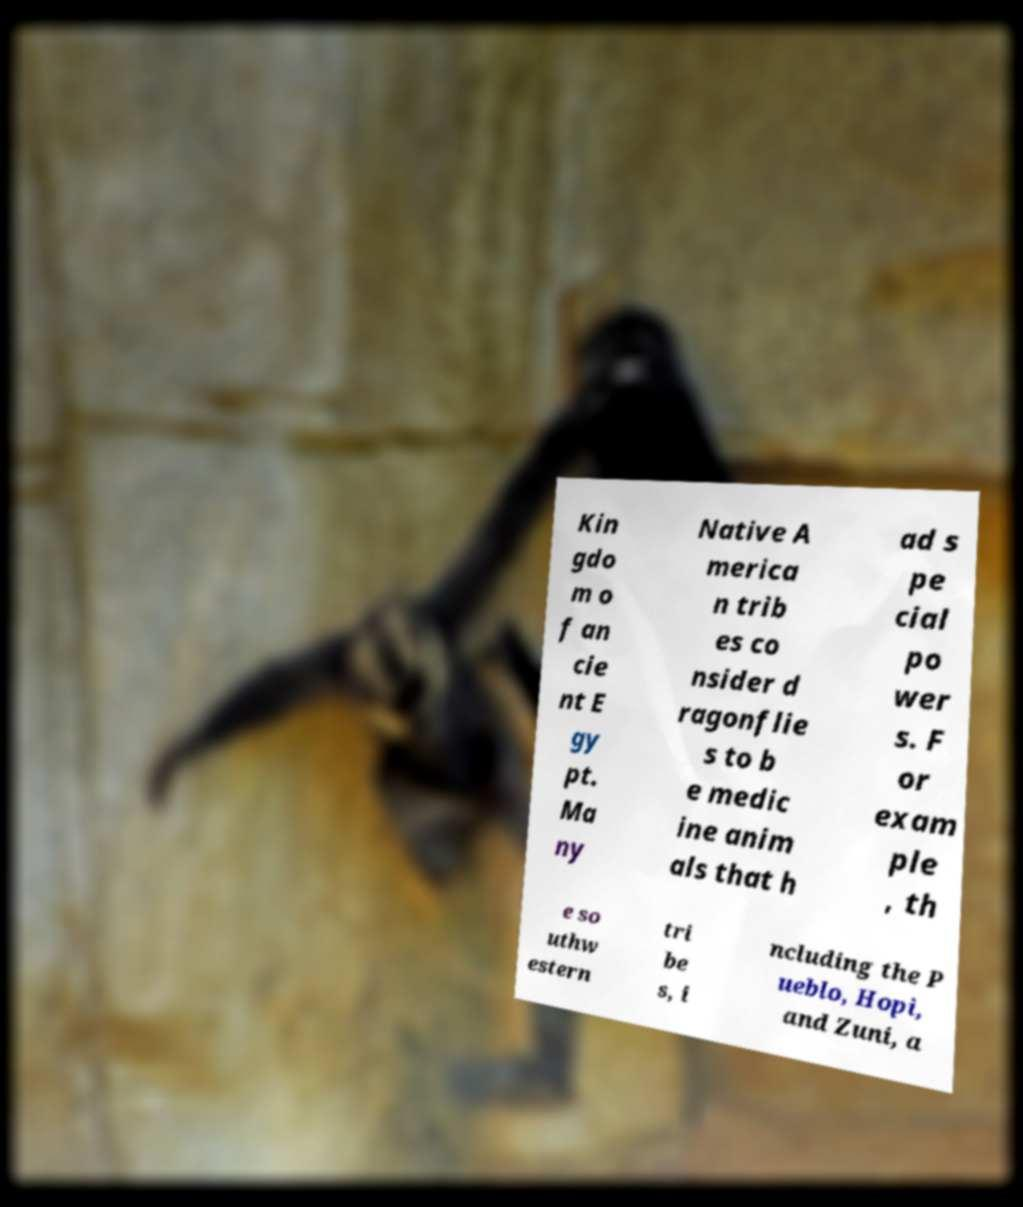Can you accurately transcribe the text from the provided image for me? Kin gdo m o f an cie nt E gy pt. Ma ny Native A merica n trib es co nsider d ragonflie s to b e medic ine anim als that h ad s pe cial po wer s. F or exam ple , th e so uthw estern tri be s, i ncluding the P ueblo, Hopi, and Zuni, a 